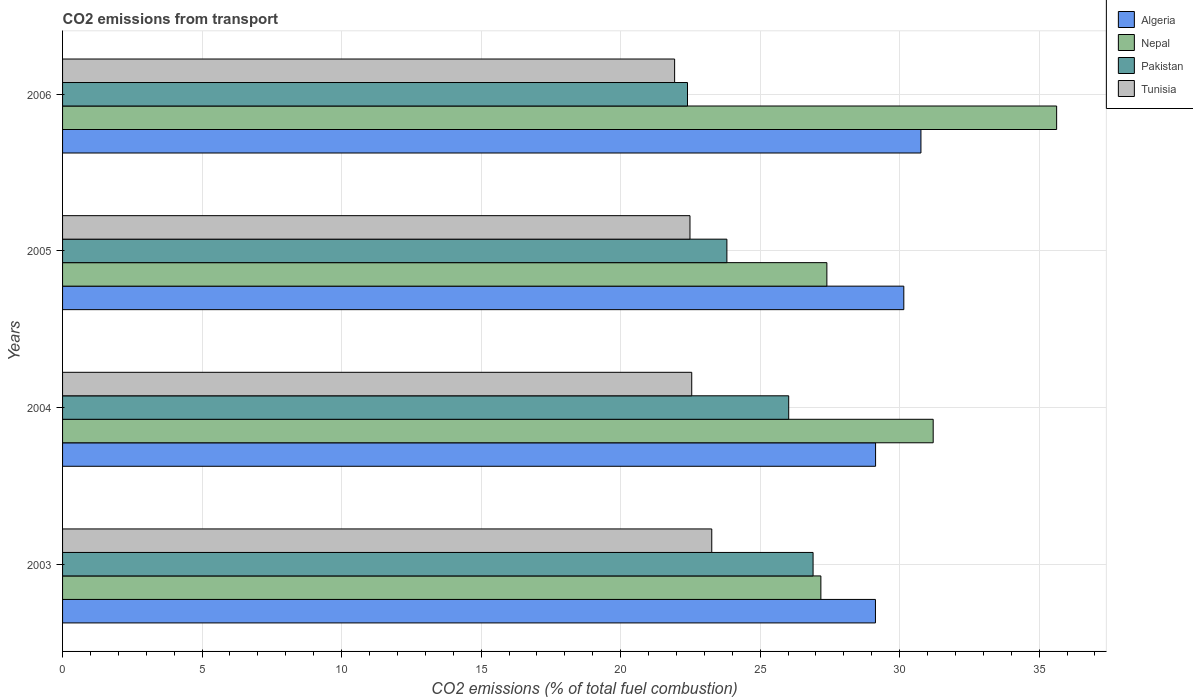How many groups of bars are there?
Your response must be concise. 4. What is the label of the 3rd group of bars from the top?
Make the answer very short. 2004. What is the total CO2 emitted in Pakistan in 2006?
Your answer should be compact. 22.4. Across all years, what is the maximum total CO2 emitted in Tunisia?
Offer a terse response. 23.27. Across all years, what is the minimum total CO2 emitted in Nepal?
Your answer should be compact. 27.18. In which year was the total CO2 emitted in Pakistan minimum?
Ensure brevity in your answer.  2006. What is the total total CO2 emitted in Nepal in the graph?
Your response must be concise. 121.4. What is the difference between the total CO2 emitted in Algeria in 2004 and that in 2005?
Make the answer very short. -1.01. What is the difference between the total CO2 emitted in Algeria in 2006 and the total CO2 emitted in Nepal in 2003?
Your response must be concise. 3.59. What is the average total CO2 emitted in Tunisia per year?
Offer a very short reply. 22.56. In the year 2003, what is the difference between the total CO2 emitted in Tunisia and total CO2 emitted in Pakistan?
Provide a short and direct response. -3.63. In how many years, is the total CO2 emitted in Pakistan greater than 34 ?
Give a very brief answer. 0. What is the ratio of the total CO2 emitted in Tunisia in 2003 to that in 2004?
Your answer should be compact. 1.03. Is the total CO2 emitted in Algeria in 2003 less than that in 2006?
Provide a short and direct response. Yes. Is the difference between the total CO2 emitted in Tunisia in 2004 and 2005 greater than the difference between the total CO2 emitted in Pakistan in 2004 and 2005?
Provide a short and direct response. No. What is the difference between the highest and the second highest total CO2 emitted in Tunisia?
Keep it short and to the point. 0.72. What is the difference between the highest and the lowest total CO2 emitted in Algeria?
Your answer should be very brief. 1.63. What does the 1st bar from the top in 2005 represents?
Make the answer very short. Tunisia. Is it the case that in every year, the sum of the total CO2 emitted in Pakistan and total CO2 emitted in Tunisia is greater than the total CO2 emitted in Algeria?
Keep it short and to the point. Yes. Are all the bars in the graph horizontal?
Your answer should be compact. Yes. Are the values on the major ticks of X-axis written in scientific E-notation?
Make the answer very short. No. Does the graph contain any zero values?
Make the answer very short. No. Does the graph contain grids?
Offer a very short reply. Yes. How many legend labels are there?
Ensure brevity in your answer.  4. How are the legend labels stacked?
Offer a very short reply. Vertical. What is the title of the graph?
Provide a succinct answer. CO2 emissions from transport. Does "Montenegro" appear as one of the legend labels in the graph?
Provide a short and direct response. No. What is the label or title of the X-axis?
Provide a succinct answer. CO2 emissions (% of total fuel combustion). What is the label or title of the Y-axis?
Ensure brevity in your answer.  Years. What is the CO2 emissions (% of total fuel combustion) of Algeria in 2003?
Make the answer very short. 29.13. What is the CO2 emissions (% of total fuel combustion) in Nepal in 2003?
Your answer should be compact. 27.18. What is the CO2 emissions (% of total fuel combustion) of Pakistan in 2003?
Your answer should be compact. 26.9. What is the CO2 emissions (% of total fuel combustion) of Tunisia in 2003?
Provide a short and direct response. 23.27. What is the CO2 emissions (% of total fuel combustion) of Algeria in 2004?
Keep it short and to the point. 29.14. What is the CO2 emissions (% of total fuel combustion) in Nepal in 2004?
Keep it short and to the point. 31.2. What is the CO2 emissions (% of total fuel combustion) of Pakistan in 2004?
Ensure brevity in your answer.  26.02. What is the CO2 emissions (% of total fuel combustion) in Tunisia in 2004?
Provide a succinct answer. 22.55. What is the CO2 emissions (% of total fuel combustion) in Algeria in 2005?
Your answer should be compact. 30.15. What is the CO2 emissions (% of total fuel combustion) of Nepal in 2005?
Your response must be concise. 27.39. What is the CO2 emissions (% of total fuel combustion) in Pakistan in 2005?
Your answer should be compact. 23.81. What is the CO2 emissions (% of total fuel combustion) in Tunisia in 2005?
Provide a succinct answer. 22.49. What is the CO2 emissions (% of total fuel combustion) of Algeria in 2006?
Provide a short and direct response. 30.76. What is the CO2 emissions (% of total fuel combustion) of Nepal in 2006?
Keep it short and to the point. 35.63. What is the CO2 emissions (% of total fuel combustion) of Pakistan in 2006?
Provide a succinct answer. 22.4. What is the CO2 emissions (% of total fuel combustion) of Tunisia in 2006?
Keep it short and to the point. 21.94. Across all years, what is the maximum CO2 emissions (% of total fuel combustion) in Algeria?
Make the answer very short. 30.76. Across all years, what is the maximum CO2 emissions (% of total fuel combustion) of Nepal?
Ensure brevity in your answer.  35.63. Across all years, what is the maximum CO2 emissions (% of total fuel combustion) in Pakistan?
Your answer should be compact. 26.9. Across all years, what is the maximum CO2 emissions (% of total fuel combustion) in Tunisia?
Your answer should be compact. 23.27. Across all years, what is the minimum CO2 emissions (% of total fuel combustion) of Algeria?
Make the answer very short. 29.13. Across all years, what is the minimum CO2 emissions (% of total fuel combustion) in Nepal?
Make the answer very short. 27.18. Across all years, what is the minimum CO2 emissions (% of total fuel combustion) of Pakistan?
Provide a succinct answer. 22.4. Across all years, what is the minimum CO2 emissions (% of total fuel combustion) in Tunisia?
Make the answer very short. 21.94. What is the total CO2 emissions (% of total fuel combustion) of Algeria in the graph?
Provide a succinct answer. 119.19. What is the total CO2 emissions (% of total fuel combustion) of Nepal in the graph?
Offer a terse response. 121.4. What is the total CO2 emissions (% of total fuel combustion) in Pakistan in the graph?
Provide a short and direct response. 99.13. What is the total CO2 emissions (% of total fuel combustion) of Tunisia in the graph?
Your response must be concise. 90.24. What is the difference between the CO2 emissions (% of total fuel combustion) of Algeria in 2003 and that in 2004?
Provide a short and direct response. -0. What is the difference between the CO2 emissions (% of total fuel combustion) in Nepal in 2003 and that in 2004?
Ensure brevity in your answer.  -4.03. What is the difference between the CO2 emissions (% of total fuel combustion) in Pakistan in 2003 and that in 2004?
Provide a short and direct response. 0.87. What is the difference between the CO2 emissions (% of total fuel combustion) in Tunisia in 2003 and that in 2004?
Provide a short and direct response. 0.72. What is the difference between the CO2 emissions (% of total fuel combustion) in Algeria in 2003 and that in 2005?
Provide a succinct answer. -1.02. What is the difference between the CO2 emissions (% of total fuel combustion) of Nepal in 2003 and that in 2005?
Your answer should be compact. -0.21. What is the difference between the CO2 emissions (% of total fuel combustion) in Pakistan in 2003 and that in 2005?
Your answer should be very brief. 3.09. What is the difference between the CO2 emissions (% of total fuel combustion) of Tunisia in 2003 and that in 2005?
Offer a terse response. 0.78. What is the difference between the CO2 emissions (% of total fuel combustion) of Algeria in 2003 and that in 2006?
Provide a short and direct response. -1.63. What is the difference between the CO2 emissions (% of total fuel combustion) in Nepal in 2003 and that in 2006?
Give a very brief answer. -8.45. What is the difference between the CO2 emissions (% of total fuel combustion) of Pakistan in 2003 and that in 2006?
Provide a succinct answer. 4.5. What is the difference between the CO2 emissions (% of total fuel combustion) of Tunisia in 2003 and that in 2006?
Your response must be concise. 1.33. What is the difference between the CO2 emissions (% of total fuel combustion) of Algeria in 2004 and that in 2005?
Your answer should be very brief. -1.01. What is the difference between the CO2 emissions (% of total fuel combustion) in Nepal in 2004 and that in 2005?
Give a very brief answer. 3.81. What is the difference between the CO2 emissions (% of total fuel combustion) of Pakistan in 2004 and that in 2005?
Make the answer very short. 2.22. What is the difference between the CO2 emissions (% of total fuel combustion) of Tunisia in 2004 and that in 2005?
Make the answer very short. 0.06. What is the difference between the CO2 emissions (% of total fuel combustion) of Algeria in 2004 and that in 2006?
Make the answer very short. -1.63. What is the difference between the CO2 emissions (% of total fuel combustion) of Nepal in 2004 and that in 2006?
Ensure brevity in your answer.  -4.42. What is the difference between the CO2 emissions (% of total fuel combustion) of Pakistan in 2004 and that in 2006?
Keep it short and to the point. 3.63. What is the difference between the CO2 emissions (% of total fuel combustion) in Tunisia in 2004 and that in 2006?
Provide a short and direct response. 0.61. What is the difference between the CO2 emissions (% of total fuel combustion) in Algeria in 2005 and that in 2006?
Offer a very short reply. -0.61. What is the difference between the CO2 emissions (% of total fuel combustion) of Nepal in 2005 and that in 2006?
Make the answer very short. -8.23. What is the difference between the CO2 emissions (% of total fuel combustion) of Pakistan in 2005 and that in 2006?
Give a very brief answer. 1.41. What is the difference between the CO2 emissions (% of total fuel combustion) in Tunisia in 2005 and that in 2006?
Offer a very short reply. 0.55. What is the difference between the CO2 emissions (% of total fuel combustion) of Algeria in 2003 and the CO2 emissions (% of total fuel combustion) of Nepal in 2004?
Ensure brevity in your answer.  -2.07. What is the difference between the CO2 emissions (% of total fuel combustion) in Algeria in 2003 and the CO2 emissions (% of total fuel combustion) in Pakistan in 2004?
Keep it short and to the point. 3.11. What is the difference between the CO2 emissions (% of total fuel combustion) in Algeria in 2003 and the CO2 emissions (% of total fuel combustion) in Tunisia in 2004?
Make the answer very short. 6.58. What is the difference between the CO2 emissions (% of total fuel combustion) of Nepal in 2003 and the CO2 emissions (% of total fuel combustion) of Pakistan in 2004?
Ensure brevity in your answer.  1.15. What is the difference between the CO2 emissions (% of total fuel combustion) of Nepal in 2003 and the CO2 emissions (% of total fuel combustion) of Tunisia in 2004?
Ensure brevity in your answer.  4.63. What is the difference between the CO2 emissions (% of total fuel combustion) of Pakistan in 2003 and the CO2 emissions (% of total fuel combustion) of Tunisia in 2004?
Make the answer very short. 4.35. What is the difference between the CO2 emissions (% of total fuel combustion) in Algeria in 2003 and the CO2 emissions (% of total fuel combustion) in Nepal in 2005?
Offer a very short reply. 1.74. What is the difference between the CO2 emissions (% of total fuel combustion) of Algeria in 2003 and the CO2 emissions (% of total fuel combustion) of Pakistan in 2005?
Keep it short and to the point. 5.32. What is the difference between the CO2 emissions (% of total fuel combustion) of Algeria in 2003 and the CO2 emissions (% of total fuel combustion) of Tunisia in 2005?
Give a very brief answer. 6.65. What is the difference between the CO2 emissions (% of total fuel combustion) in Nepal in 2003 and the CO2 emissions (% of total fuel combustion) in Pakistan in 2005?
Provide a short and direct response. 3.37. What is the difference between the CO2 emissions (% of total fuel combustion) in Nepal in 2003 and the CO2 emissions (% of total fuel combustion) in Tunisia in 2005?
Give a very brief answer. 4.69. What is the difference between the CO2 emissions (% of total fuel combustion) in Pakistan in 2003 and the CO2 emissions (% of total fuel combustion) in Tunisia in 2005?
Your answer should be compact. 4.41. What is the difference between the CO2 emissions (% of total fuel combustion) of Algeria in 2003 and the CO2 emissions (% of total fuel combustion) of Nepal in 2006?
Make the answer very short. -6.49. What is the difference between the CO2 emissions (% of total fuel combustion) in Algeria in 2003 and the CO2 emissions (% of total fuel combustion) in Pakistan in 2006?
Your answer should be compact. 6.74. What is the difference between the CO2 emissions (% of total fuel combustion) in Algeria in 2003 and the CO2 emissions (% of total fuel combustion) in Tunisia in 2006?
Your answer should be very brief. 7.2. What is the difference between the CO2 emissions (% of total fuel combustion) in Nepal in 2003 and the CO2 emissions (% of total fuel combustion) in Pakistan in 2006?
Provide a succinct answer. 4.78. What is the difference between the CO2 emissions (% of total fuel combustion) of Nepal in 2003 and the CO2 emissions (% of total fuel combustion) of Tunisia in 2006?
Offer a very short reply. 5.24. What is the difference between the CO2 emissions (% of total fuel combustion) in Pakistan in 2003 and the CO2 emissions (% of total fuel combustion) in Tunisia in 2006?
Your response must be concise. 4.96. What is the difference between the CO2 emissions (% of total fuel combustion) of Algeria in 2004 and the CO2 emissions (% of total fuel combustion) of Nepal in 2005?
Make the answer very short. 1.75. What is the difference between the CO2 emissions (% of total fuel combustion) of Algeria in 2004 and the CO2 emissions (% of total fuel combustion) of Pakistan in 2005?
Keep it short and to the point. 5.33. What is the difference between the CO2 emissions (% of total fuel combustion) of Algeria in 2004 and the CO2 emissions (% of total fuel combustion) of Tunisia in 2005?
Provide a succinct answer. 6.65. What is the difference between the CO2 emissions (% of total fuel combustion) in Nepal in 2004 and the CO2 emissions (% of total fuel combustion) in Pakistan in 2005?
Offer a very short reply. 7.39. What is the difference between the CO2 emissions (% of total fuel combustion) of Nepal in 2004 and the CO2 emissions (% of total fuel combustion) of Tunisia in 2005?
Provide a short and direct response. 8.72. What is the difference between the CO2 emissions (% of total fuel combustion) in Pakistan in 2004 and the CO2 emissions (% of total fuel combustion) in Tunisia in 2005?
Offer a terse response. 3.54. What is the difference between the CO2 emissions (% of total fuel combustion) of Algeria in 2004 and the CO2 emissions (% of total fuel combustion) of Nepal in 2006?
Offer a terse response. -6.49. What is the difference between the CO2 emissions (% of total fuel combustion) of Algeria in 2004 and the CO2 emissions (% of total fuel combustion) of Pakistan in 2006?
Keep it short and to the point. 6.74. What is the difference between the CO2 emissions (% of total fuel combustion) of Algeria in 2004 and the CO2 emissions (% of total fuel combustion) of Tunisia in 2006?
Ensure brevity in your answer.  7.2. What is the difference between the CO2 emissions (% of total fuel combustion) of Nepal in 2004 and the CO2 emissions (% of total fuel combustion) of Pakistan in 2006?
Keep it short and to the point. 8.81. What is the difference between the CO2 emissions (% of total fuel combustion) in Nepal in 2004 and the CO2 emissions (% of total fuel combustion) in Tunisia in 2006?
Offer a very short reply. 9.27. What is the difference between the CO2 emissions (% of total fuel combustion) in Pakistan in 2004 and the CO2 emissions (% of total fuel combustion) in Tunisia in 2006?
Your response must be concise. 4.09. What is the difference between the CO2 emissions (% of total fuel combustion) of Algeria in 2005 and the CO2 emissions (% of total fuel combustion) of Nepal in 2006?
Offer a terse response. -5.48. What is the difference between the CO2 emissions (% of total fuel combustion) of Algeria in 2005 and the CO2 emissions (% of total fuel combustion) of Pakistan in 2006?
Give a very brief answer. 7.75. What is the difference between the CO2 emissions (% of total fuel combustion) of Algeria in 2005 and the CO2 emissions (% of total fuel combustion) of Tunisia in 2006?
Provide a succinct answer. 8.21. What is the difference between the CO2 emissions (% of total fuel combustion) of Nepal in 2005 and the CO2 emissions (% of total fuel combustion) of Pakistan in 2006?
Offer a terse response. 5. What is the difference between the CO2 emissions (% of total fuel combustion) of Nepal in 2005 and the CO2 emissions (% of total fuel combustion) of Tunisia in 2006?
Your answer should be compact. 5.46. What is the difference between the CO2 emissions (% of total fuel combustion) of Pakistan in 2005 and the CO2 emissions (% of total fuel combustion) of Tunisia in 2006?
Give a very brief answer. 1.87. What is the average CO2 emissions (% of total fuel combustion) in Algeria per year?
Your answer should be very brief. 29.8. What is the average CO2 emissions (% of total fuel combustion) in Nepal per year?
Give a very brief answer. 30.35. What is the average CO2 emissions (% of total fuel combustion) in Pakistan per year?
Give a very brief answer. 24.78. What is the average CO2 emissions (% of total fuel combustion) in Tunisia per year?
Offer a very short reply. 22.56. In the year 2003, what is the difference between the CO2 emissions (% of total fuel combustion) in Algeria and CO2 emissions (% of total fuel combustion) in Nepal?
Your answer should be very brief. 1.96. In the year 2003, what is the difference between the CO2 emissions (% of total fuel combustion) of Algeria and CO2 emissions (% of total fuel combustion) of Pakistan?
Provide a succinct answer. 2.24. In the year 2003, what is the difference between the CO2 emissions (% of total fuel combustion) of Algeria and CO2 emissions (% of total fuel combustion) of Tunisia?
Ensure brevity in your answer.  5.87. In the year 2003, what is the difference between the CO2 emissions (% of total fuel combustion) of Nepal and CO2 emissions (% of total fuel combustion) of Pakistan?
Offer a terse response. 0.28. In the year 2003, what is the difference between the CO2 emissions (% of total fuel combustion) of Nepal and CO2 emissions (% of total fuel combustion) of Tunisia?
Provide a short and direct response. 3.91. In the year 2003, what is the difference between the CO2 emissions (% of total fuel combustion) in Pakistan and CO2 emissions (% of total fuel combustion) in Tunisia?
Your response must be concise. 3.63. In the year 2004, what is the difference between the CO2 emissions (% of total fuel combustion) of Algeria and CO2 emissions (% of total fuel combustion) of Nepal?
Keep it short and to the point. -2.06. In the year 2004, what is the difference between the CO2 emissions (% of total fuel combustion) of Algeria and CO2 emissions (% of total fuel combustion) of Pakistan?
Your answer should be very brief. 3.11. In the year 2004, what is the difference between the CO2 emissions (% of total fuel combustion) in Algeria and CO2 emissions (% of total fuel combustion) in Tunisia?
Give a very brief answer. 6.59. In the year 2004, what is the difference between the CO2 emissions (% of total fuel combustion) of Nepal and CO2 emissions (% of total fuel combustion) of Pakistan?
Make the answer very short. 5.18. In the year 2004, what is the difference between the CO2 emissions (% of total fuel combustion) in Nepal and CO2 emissions (% of total fuel combustion) in Tunisia?
Your answer should be compact. 8.65. In the year 2004, what is the difference between the CO2 emissions (% of total fuel combustion) in Pakistan and CO2 emissions (% of total fuel combustion) in Tunisia?
Your answer should be very brief. 3.48. In the year 2005, what is the difference between the CO2 emissions (% of total fuel combustion) in Algeria and CO2 emissions (% of total fuel combustion) in Nepal?
Give a very brief answer. 2.76. In the year 2005, what is the difference between the CO2 emissions (% of total fuel combustion) of Algeria and CO2 emissions (% of total fuel combustion) of Pakistan?
Offer a terse response. 6.34. In the year 2005, what is the difference between the CO2 emissions (% of total fuel combustion) in Algeria and CO2 emissions (% of total fuel combustion) in Tunisia?
Give a very brief answer. 7.66. In the year 2005, what is the difference between the CO2 emissions (% of total fuel combustion) in Nepal and CO2 emissions (% of total fuel combustion) in Pakistan?
Give a very brief answer. 3.58. In the year 2005, what is the difference between the CO2 emissions (% of total fuel combustion) in Nepal and CO2 emissions (% of total fuel combustion) in Tunisia?
Ensure brevity in your answer.  4.91. In the year 2005, what is the difference between the CO2 emissions (% of total fuel combustion) of Pakistan and CO2 emissions (% of total fuel combustion) of Tunisia?
Give a very brief answer. 1.32. In the year 2006, what is the difference between the CO2 emissions (% of total fuel combustion) of Algeria and CO2 emissions (% of total fuel combustion) of Nepal?
Provide a succinct answer. -4.86. In the year 2006, what is the difference between the CO2 emissions (% of total fuel combustion) of Algeria and CO2 emissions (% of total fuel combustion) of Pakistan?
Your response must be concise. 8.37. In the year 2006, what is the difference between the CO2 emissions (% of total fuel combustion) of Algeria and CO2 emissions (% of total fuel combustion) of Tunisia?
Your answer should be very brief. 8.83. In the year 2006, what is the difference between the CO2 emissions (% of total fuel combustion) in Nepal and CO2 emissions (% of total fuel combustion) in Pakistan?
Make the answer very short. 13.23. In the year 2006, what is the difference between the CO2 emissions (% of total fuel combustion) in Nepal and CO2 emissions (% of total fuel combustion) in Tunisia?
Provide a succinct answer. 13.69. In the year 2006, what is the difference between the CO2 emissions (% of total fuel combustion) of Pakistan and CO2 emissions (% of total fuel combustion) of Tunisia?
Offer a terse response. 0.46. What is the ratio of the CO2 emissions (% of total fuel combustion) of Algeria in 2003 to that in 2004?
Your response must be concise. 1. What is the ratio of the CO2 emissions (% of total fuel combustion) of Nepal in 2003 to that in 2004?
Keep it short and to the point. 0.87. What is the ratio of the CO2 emissions (% of total fuel combustion) in Pakistan in 2003 to that in 2004?
Your response must be concise. 1.03. What is the ratio of the CO2 emissions (% of total fuel combustion) in Tunisia in 2003 to that in 2004?
Offer a very short reply. 1.03. What is the ratio of the CO2 emissions (% of total fuel combustion) in Algeria in 2003 to that in 2005?
Make the answer very short. 0.97. What is the ratio of the CO2 emissions (% of total fuel combustion) in Nepal in 2003 to that in 2005?
Make the answer very short. 0.99. What is the ratio of the CO2 emissions (% of total fuel combustion) in Pakistan in 2003 to that in 2005?
Give a very brief answer. 1.13. What is the ratio of the CO2 emissions (% of total fuel combustion) of Tunisia in 2003 to that in 2005?
Offer a very short reply. 1.03. What is the ratio of the CO2 emissions (% of total fuel combustion) of Algeria in 2003 to that in 2006?
Provide a succinct answer. 0.95. What is the ratio of the CO2 emissions (% of total fuel combustion) of Nepal in 2003 to that in 2006?
Your answer should be compact. 0.76. What is the ratio of the CO2 emissions (% of total fuel combustion) in Pakistan in 2003 to that in 2006?
Offer a very short reply. 1.2. What is the ratio of the CO2 emissions (% of total fuel combustion) in Tunisia in 2003 to that in 2006?
Your answer should be very brief. 1.06. What is the ratio of the CO2 emissions (% of total fuel combustion) in Algeria in 2004 to that in 2005?
Ensure brevity in your answer.  0.97. What is the ratio of the CO2 emissions (% of total fuel combustion) in Nepal in 2004 to that in 2005?
Ensure brevity in your answer.  1.14. What is the ratio of the CO2 emissions (% of total fuel combustion) in Pakistan in 2004 to that in 2005?
Your answer should be very brief. 1.09. What is the ratio of the CO2 emissions (% of total fuel combustion) of Tunisia in 2004 to that in 2005?
Your answer should be compact. 1. What is the ratio of the CO2 emissions (% of total fuel combustion) in Algeria in 2004 to that in 2006?
Provide a short and direct response. 0.95. What is the ratio of the CO2 emissions (% of total fuel combustion) in Nepal in 2004 to that in 2006?
Your answer should be very brief. 0.88. What is the ratio of the CO2 emissions (% of total fuel combustion) of Pakistan in 2004 to that in 2006?
Offer a terse response. 1.16. What is the ratio of the CO2 emissions (% of total fuel combustion) in Tunisia in 2004 to that in 2006?
Provide a succinct answer. 1.03. What is the ratio of the CO2 emissions (% of total fuel combustion) in Algeria in 2005 to that in 2006?
Give a very brief answer. 0.98. What is the ratio of the CO2 emissions (% of total fuel combustion) of Nepal in 2005 to that in 2006?
Your response must be concise. 0.77. What is the ratio of the CO2 emissions (% of total fuel combustion) of Pakistan in 2005 to that in 2006?
Ensure brevity in your answer.  1.06. What is the ratio of the CO2 emissions (% of total fuel combustion) in Tunisia in 2005 to that in 2006?
Your answer should be compact. 1.03. What is the difference between the highest and the second highest CO2 emissions (% of total fuel combustion) of Algeria?
Your response must be concise. 0.61. What is the difference between the highest and the second highest CO2 emissions (% of total fuel combustion) of Nepal?
Your response must be concise. 4.42. What is the difference between the highest and the second highest CO2 emissions (% of total fuel combustion) in Pakistan?
Your answer should be compact. 0.87. What is the difference between the highest and the second highest CO2 emissions (% of total fuel combustion) of Tunisia?
Keep it short and to the point. 0.72. What is the difference between the highest and the lowest CO2 emissions (% of total fuel combustion) of Algeria?
Provide a short and direct response. 1.63. What is the difference between the highest and the lowest CO2 emissions (% of total fuel combustion) in Nepal?
Your answer should be very brief. 8.45. What is the difference between the highest and the lowest CO2 emissions (% of total fuel combustion) in Pakistan?
Provide a short and direct response. 4.5. What is the difference between the highest and the lowest CO2 emissions (% of total fuel combustion) of Tunisia?
Make the answer very short. 1.33. 